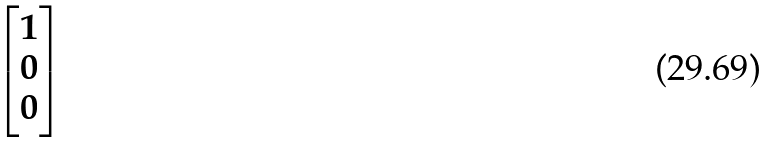Convert formula to latex. <formula><loc_0><loc_0><loc_500><loc_500>\begin{bmatrix} 1 \\ 0 \\ 0 \end{bmatrix}</formula> 